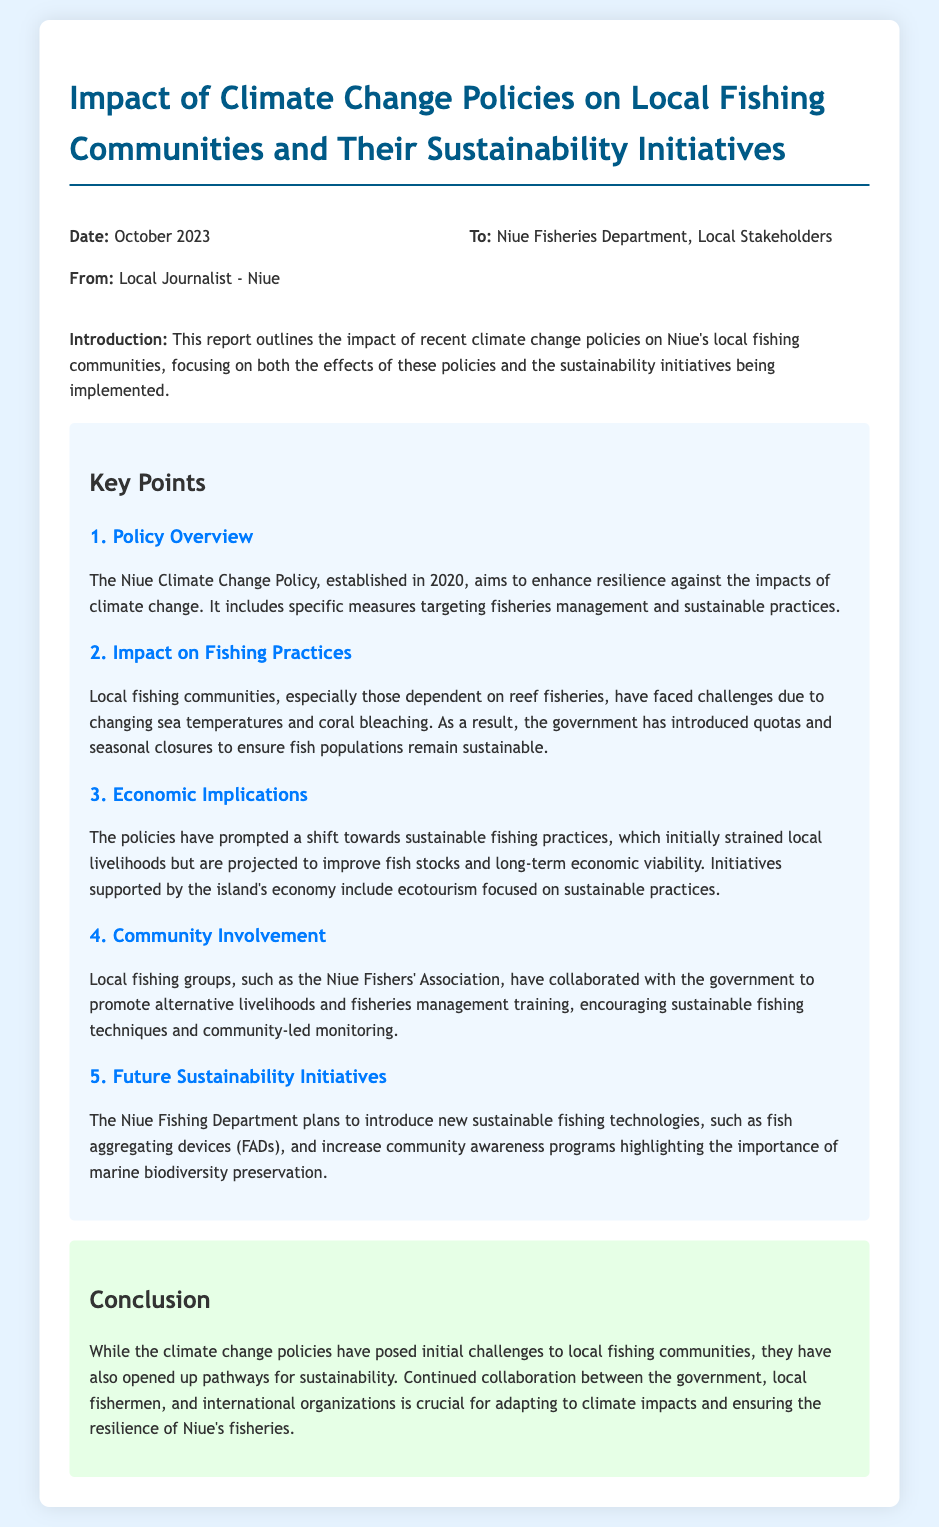What is the date of the report? The date of the report is stated clearly at the beginning of the document.
Answer: October 2023 Who is the report from? The report is addressed from a local journalist to various stakeholders.
Answer: Local Journalist - Niue What is the main goal of the Niue Climate Change Policy? The document mentions the aim of the policy in the key points section.
Answer: Enhance resilience against the impacts of climate change What fishing practice has been introduced as a response to climate change? The report highlights specific measures introduced in response to challenges faced by local fishing communities.
Answer: Quotas and seasonal closures Which local group collaborates with the government for fisheries management training? The report mentions a specific local fishing group involved in sustainability initiatives.
Answer: Niue Fishers' Association What is one proposed future initiative by the Niue Fishing Department? Future initiatives are listed in the key points section, indicating planned developments in fishing practices.
Answer: Fish aggregating devices (FADs) What initial effect did climate change policies have on local livelihoods? The document states the economic implications of the policies in relation to local livelihoods.
Answer: Strained What is essential for the resilience of Niue's fisheries? The conclusion indicates ongoing collaboration's importance for future sustainability.
Answer: Continued collaboration 